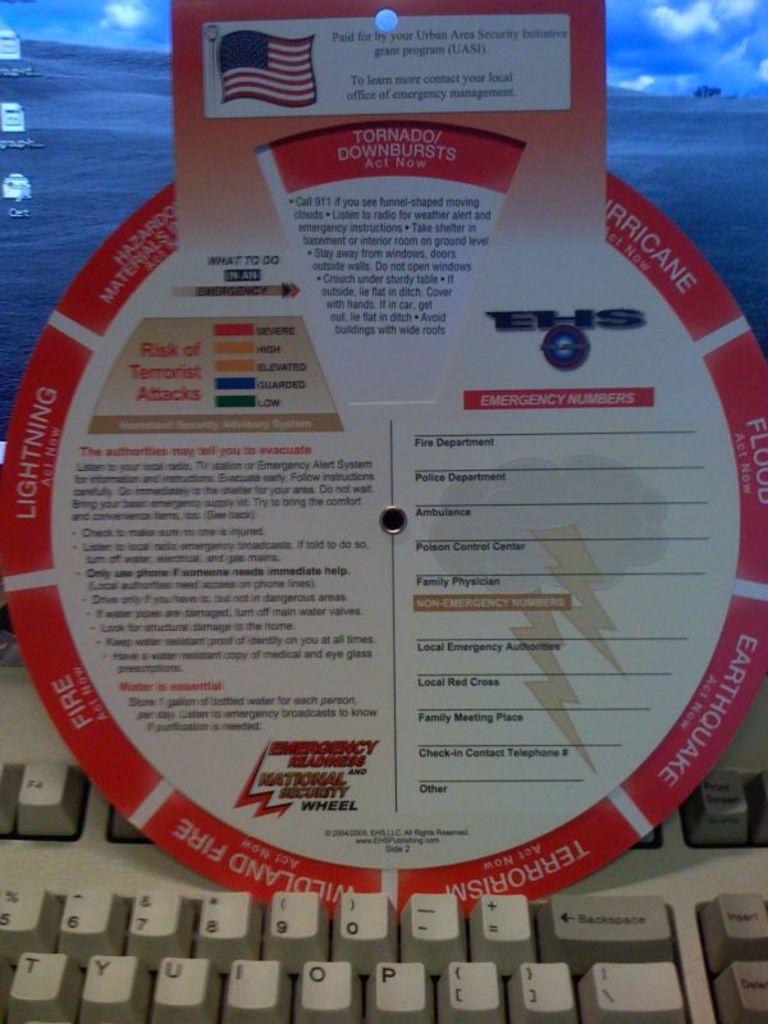What disaster is in the window?
Your answer should be very brief. Tornado. What are the risk colors for?
Provide a short and direct response. Terrorist attacks. 